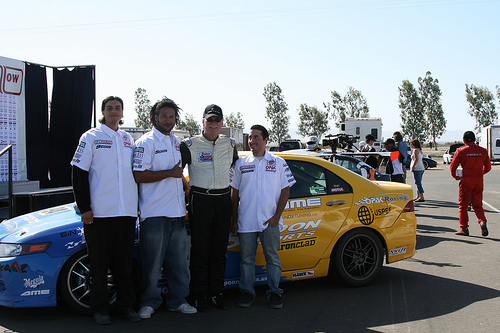<image>
Can you confirm if the man is behind the car? No. The man is not behind the car. From this viewpoint, the man appears to be positioned elsewhere in the scene. Where is the man in relation to the car? Is it in the car? No. The man is not contained within the car. These objects have a different spatial relationship. 